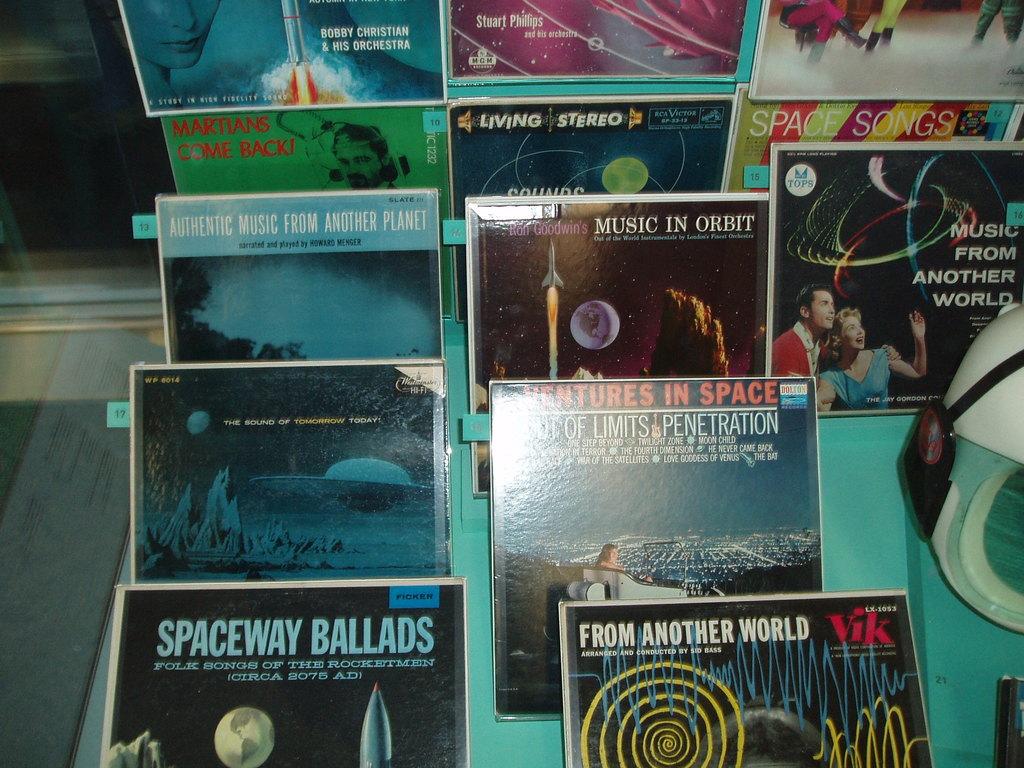What is the word before ballads?
Provide a succinct answer. Spaceway. 